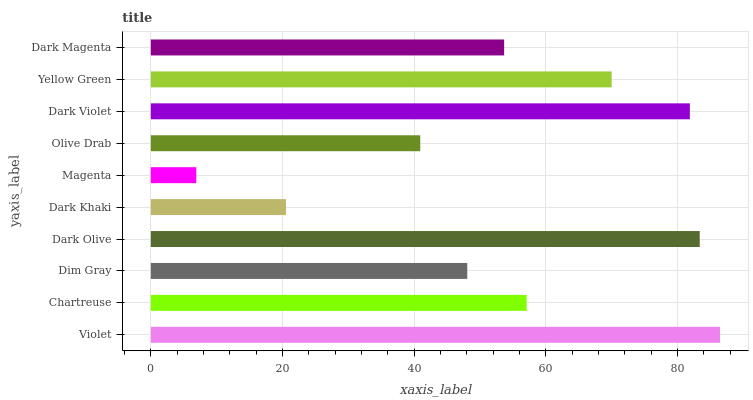Is Magenta the minimum?
Answer yes or no. Yes. Is Violet the maximum?
Answer yes or no. Yes. Is Chartreuse the minimum?
Answer yes or no. No. Is Chartreuse the maximum?
Answer yes or no. No. Is Violet greater than Chartreuse?
Answer yes or no. Yes. Is Chartreuse less than Violet?
Answer yes or no. Yes. Is Chartreuse greater than Violet?
Answer yes or no. No. Is Violet less than Chartreuse?
Answer yes or no. No. Is Chartreuse the high median?
Answer yes or no. Yes. Is Dark Magenta the low median?
Answer yes or no. Yes. Is Yellow Green the high median?
Answer yes or no. No. Is Dark Khaki the low median?
Answer yes or no. No. 